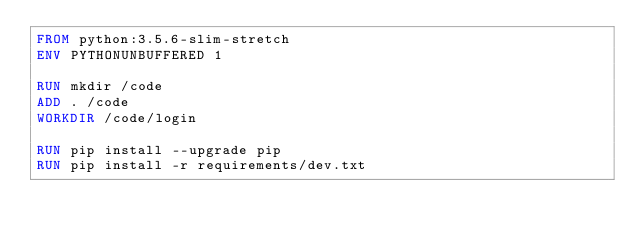<code> <loc_0><loc_0><loc_500><loc_500><_Dockerfile_>FROM python:3.5.6-slim-stretch
ENV PYTHONUNBUFFERED 1

RUN mkdir /code
ADD . /code
WORKDIR /code/login

RUN pip install --upgrade pip
RUN pip install -r requirements/dev.txt
</code> 